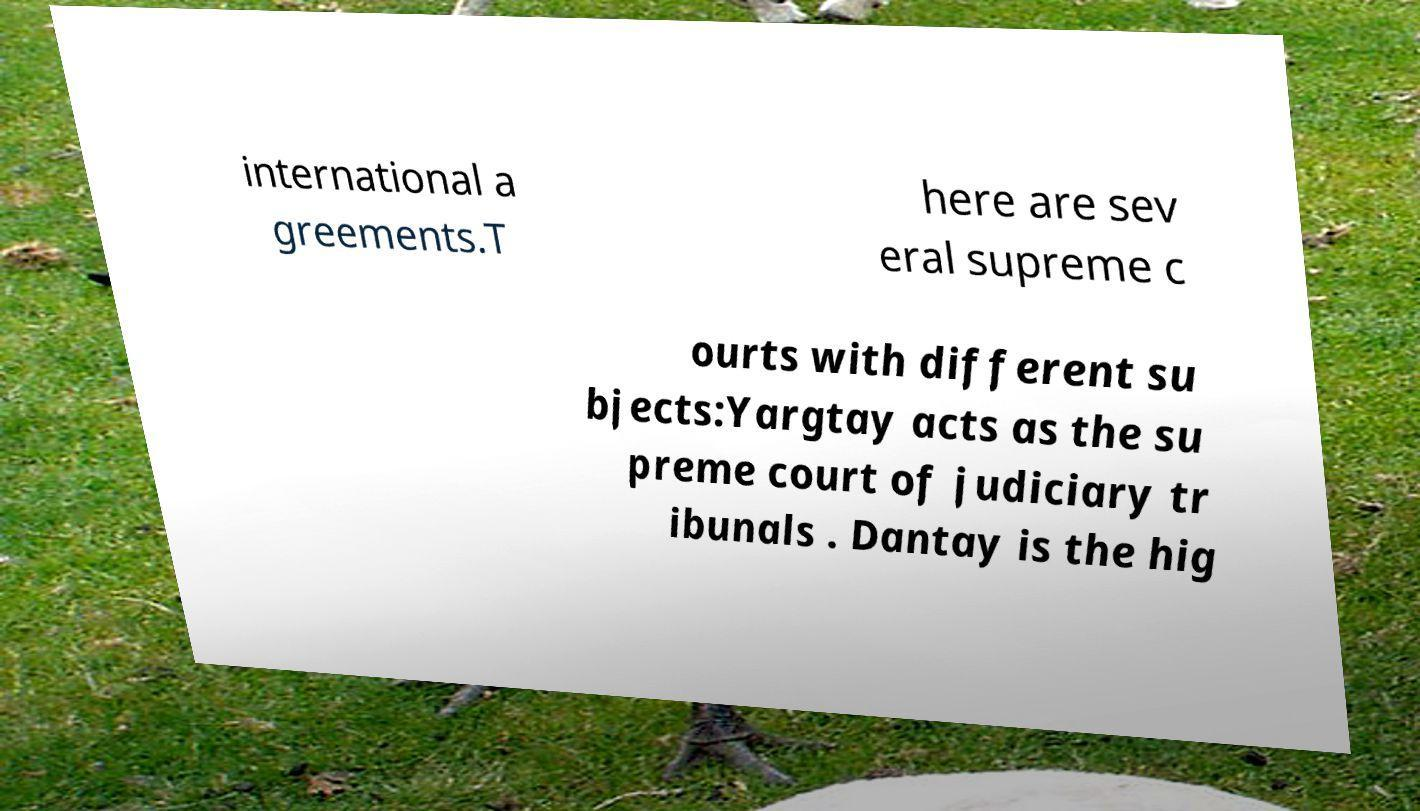There's text embedded in this image that I need extracted. Can you transcribe it verbatim? international a greements.T here are sev eral supreme c ourts with different su bjects:Yargtay acts as the su preme court of judiciary tr ibunals . Dantay is the hig 